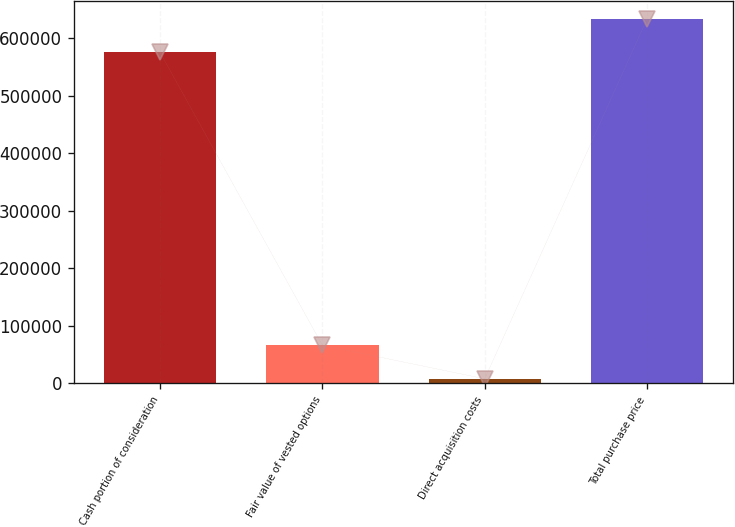Convert chart to OTSL. <chart><loc_0><loc_0><loc_500><loc_500><bar_chart><fcel>Cash portion of consideration<fcel>Fair value of vested options<fcel>Direct acquisition costs<fcel>Total purchase price<nl><fcel>575400<fcel>65950<fcel>7600<fcel>633750<nl></chart> 